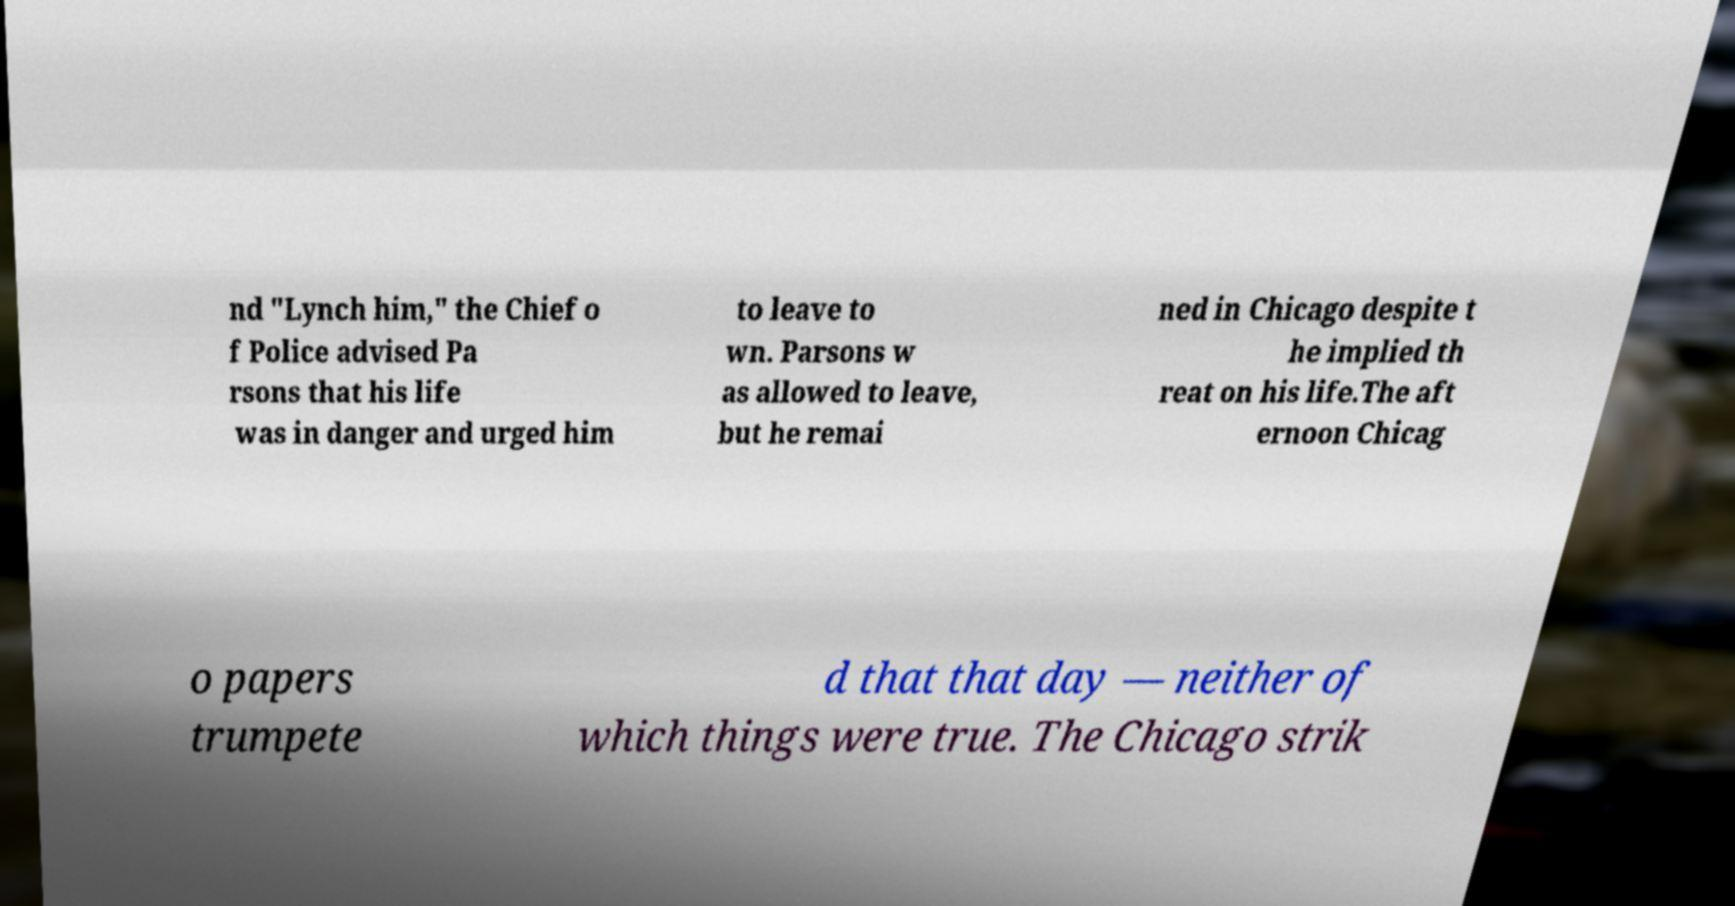Can you read and provide the text displayed in the image?This photo seems to have some interesting text. Can you extract and type it out for me? nd "Lynch him," the Chief o f Police advised Pa rsons that his life was in danger and urged him to leave to wn. Parsons w as allowed to leave, but he remai ned in Chicago despite t he implied th reat on his life.The aft ernoon Chicag o papers trumpete d that that day — neither of which things were true. The Chicago strik 